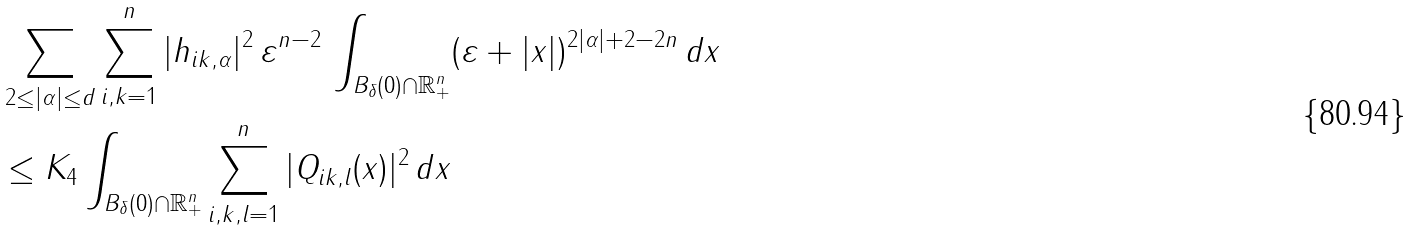<formula> <loc_0><loc_0><loc_500><loc_500>& \sum _ { 2 \leq | \alpha | \leq d } \sum _ { i , k = 1 } ^ { n } | h _ { i k , \alpha } | ^ { 2 } \, \varepsilon ^ { n - 2 } \, \int _ { B _ { \delta } ( 0 ) \cap \mathbb { R } _ { + } ^ { n } } ( \varepsilon + | x | ) ^ { 2 | \alpha | + 2 - 2 n } \, d x \\ & \leq K _ { 4 } \int _ { B _ { \delta } ( 0 ) \cap \mathbb { R } _ { + } ^ { n } } \sum _ { i , k , l = 1 } ^ { n } | Q _ { i k , l } ( x ) | ^ { 2 } \, d x</formula> 